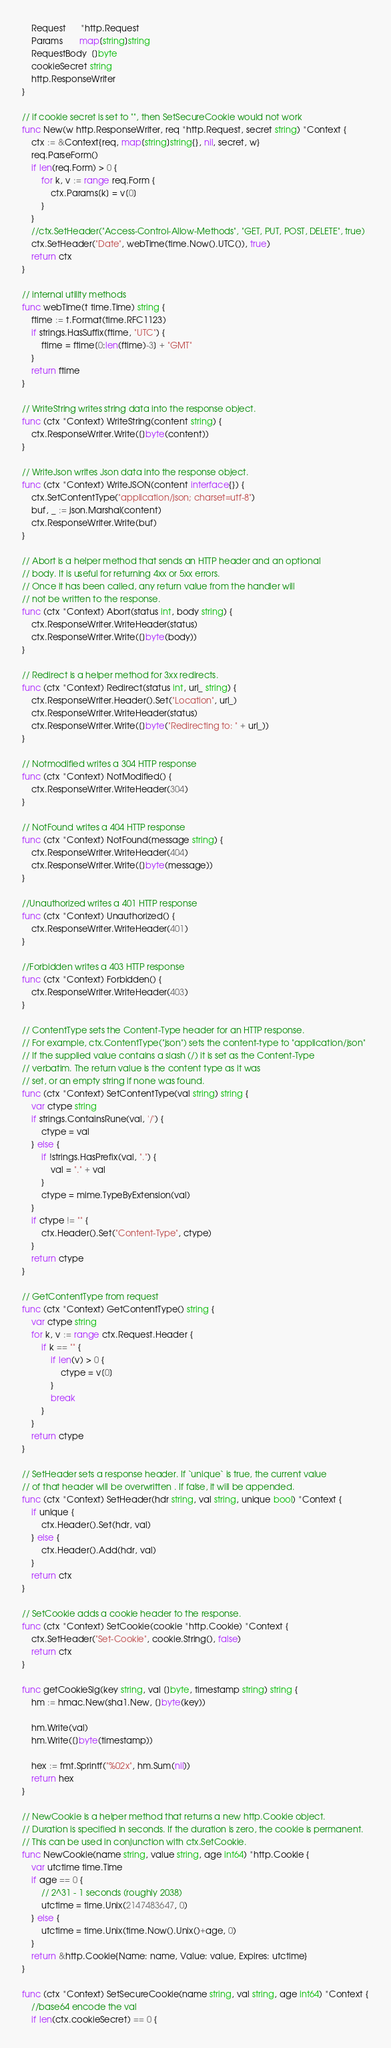<code> <loc_0><loc_0><loc_500><loc_500><_Go_>	Request      *http.Request
	Params       map[string]string
	RequestBody  []byte
	cookieSecret string
	http.ResponseWriter
}

// if cookie secret is set to "", then SetSecureCookie would not work
func New(w http.ResponseWriter, req *http.Request, secret string) *Context {
	ctx := &Context{req, map[string]string{}, nil, secret, w}
	req.ParseForm()
	if len(req.Form) > 0 {
		for k, v := range req.Form {
			ctx.Params[k] = v[0]
		}
	}
	//ctx.SetHeader("Access-Control-Allow-Methods", "GET, PUT, POST, DELETE", true)
	ctx.SetHeader("Date", webTime(time.Now().UTC()), true)
	return ctx
}

// internal utility methods
func webTime(t time.Time) string {
	ftime := t.Format(time.RFC1123)
	if strings.HasSuffix(ftime, "UTC") {
		ftime = ftime[0:len(ftime)-3] + "GMT"
	}
	return ftime
}

// WriteString writes string data into the response object.
func (ctx *Context) WriteString(content string) {
	ctx.ResponseWriter.Write([]byte(content))
}

// WriteJson writes Json data into the response object.
func (ctx *Context) WriteJSON(content interface{}) {
	ctx.SetContentType("application/json; charset=utf-8")
	buf, _ := json.Marshal(content)
	ctx.ResponseWriter.Write(buf)
}

// Abort is a helper method that sends an HTTP header and an optional
// body. It is useful for returning 4xx or 5xx errors.
// Once it has been called, any return value from the handler will
// not be written to the response.
func (ctx *Context) Abort(status int, body string) {
	ctx.ResponseWriter.WriteHeader(status)
	ctx.ResponseWriter.Write([]byte(body))
}

// Redirect is a helper method for 3xx redirects.
func (ctx *Context) Redirect(status int, url_ string) {
	ctx.ResponseWriter.Header().Set("Location", url_)
	ctx.ResponseWriter.WriteHeader(status)
	ctx.ResponseWriter.Write([]byte("Redirecting to: " + url_))
}

// Notmodified writes a 304 HTTP response
func (ctx *Context) NotModified() {
	ctx.ResponseWriter.WriteHeader(304)
}

// NotFound writes a 404 HTTP response
func (ctx *Context) NotFound(message string) {
	ctx.ResponseWriter.WriteHeader(404)
	ctx.ResponseWriter.Write([]byte(message))
}

//Unauthorized writes a 401 HTTP response
func (ctx *Context) Unauthorized() {
	ctx.ResponseWriter.WriteHeader(401)
}

//Forbidden writes a 403 HTTP response
func (ctx *Context) Forbidden() {
	ctx.ResponseWriter.WriteHeader(403)
}

// ContentType sets the Content-Type header for an HTTP response.
// For example, ctx.ContentType("json") sets the content-type to "application/json"
// If the supplied value contains a slash (/) it is set as the Content-Type
// verbatim. The return value is the content type as it was
// set, or an empty string if none was found.
func (ctx *Context) SetContentType(val string) string {
	var ctype string
	if strings.ContainsRune(val, '/') {
		ctype = val
	} else {
		if !strings.HasPrefix(val, ".") {
			val = "." + val
		}
		ctype = mime.TypeByExtension(val)
	}
	if ctype != "" {
		ctx.Header().Set("Content-Type", ctype)
	}
	return ctype
}

// GetContentType from request
func (ctx *Context) GetContentType() string {
	var ctype string
	for k, v := range ctx.Request.Header {
		if k == "" {
			if len(v) > 0 {
				ctype = v[0]
			}
			break
		}
	}
	return ctype
}

// SetHeader sets a response header. If `unique` is true, the current value
// of that header will be overwritten . If false, it will be appended.
func (ctx *Context) SetHeader(hdr string, val string, unique bool) *Context {
	if unique {
		ctx.Header().Set(hdr, val)
	} else {
		ctx.Header().Add(hdr, val)
	}
	return ctx
}

// SetCookie adds a cookie header to the response.
func (ctx *Context) SetCookie(cookie *http.Cookie) *Context {
	ctx.SetHeader("Set-Cookie", cookie.String(), false)
	return ctx
}

func getCookieSig(key string, val []byte, timestamp string) string {
	hm := hmac.New(sha1.New, []byte(key))

	hm.Write(val)
	hm.Write([]byte(timestamp))

	hex := fmt.Sprintf("%02x", hm.Sum(nil))
	return hex
}

// NewCookie is a helper method that returns a new http.Cookie object.
// Duration is specified in seconds. If the duration is zero, the cookie is permanent.
// This can be used in conjunction with ctx.SetCookie.
func NewCookie(name string, value string, age int64) *http.Cookie {
	var utctime time.Time
	if age == 0 {
		// 2^31 - 1 seconds (roughly 2038)
		utctime = time.Unix(2147483647, 0)
	} else {
		utctime = time.Unix(time.Now().Unix()+age, 0)
	}
	return &http.Cookie{Name: name, Value: value, Expires: utctime}
}

func (ctx *Context) SetSecureCookie(name string, val string, age int64) *Context {
	//base64 encode the val
	if len(ctx.cookieSecret) == 0 {</code> 